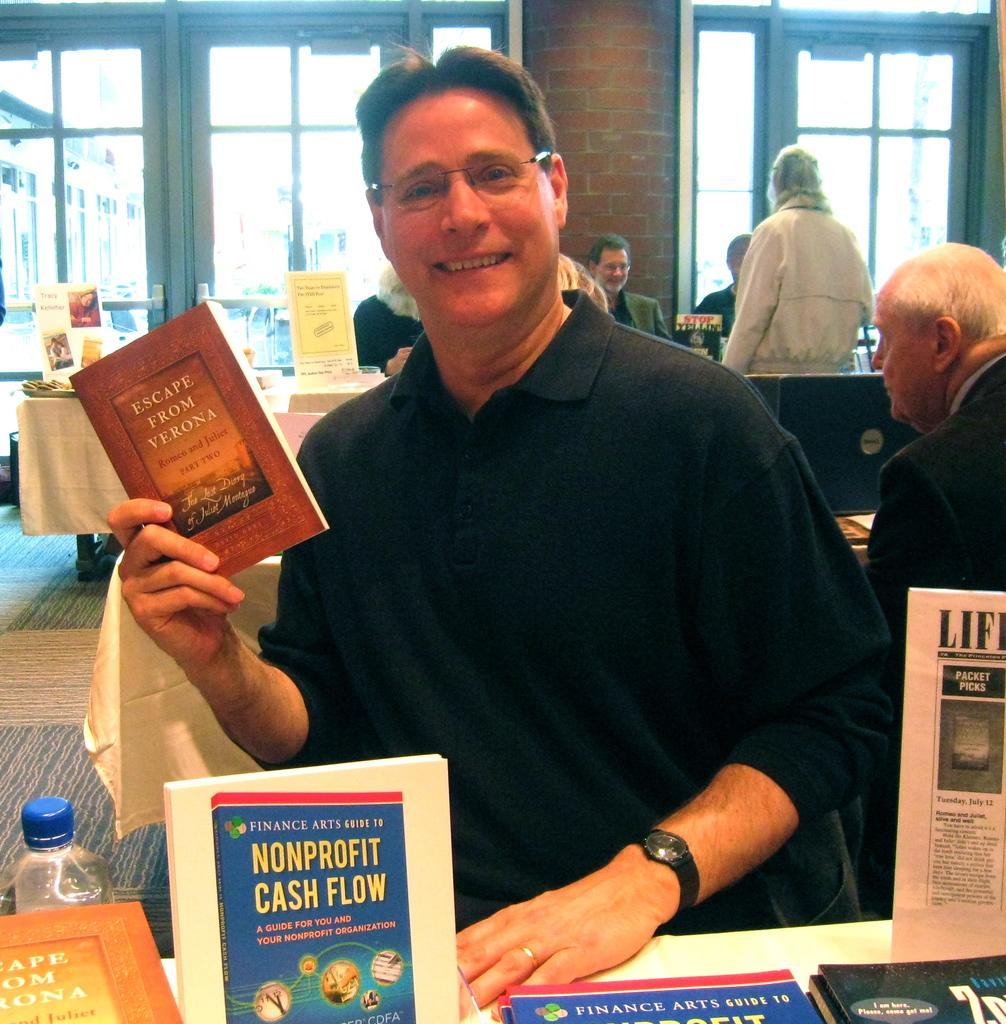<image>
Describe the image concisely. Man in front of some books while holding a book called "Escape From Verona". 